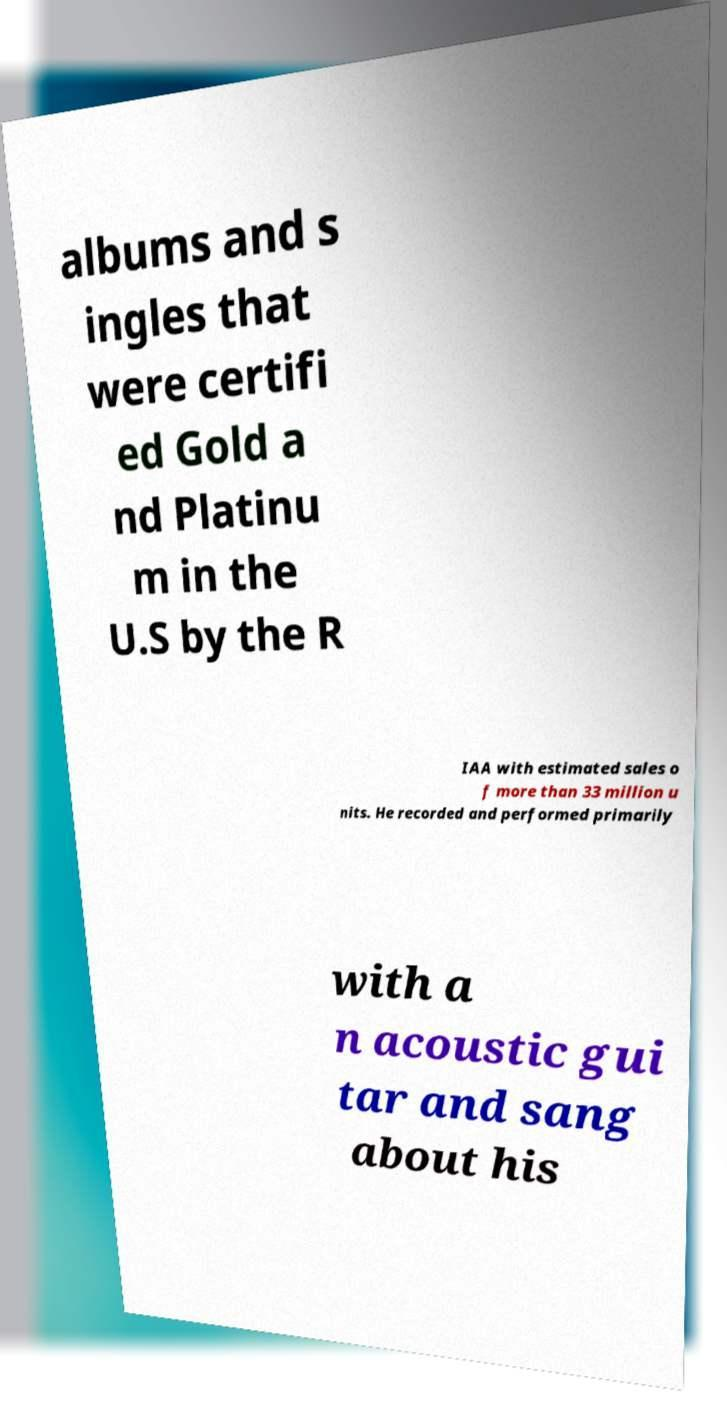Please identify and transcribe the text found in this image. albums and s ingles that were certifi ed Gold a nd Platinu m in the U.S by the R IAA with estimated sales o f more than 33 million u nits. He recorded and performed primarily with a n acoustic gui tar and sang about his 